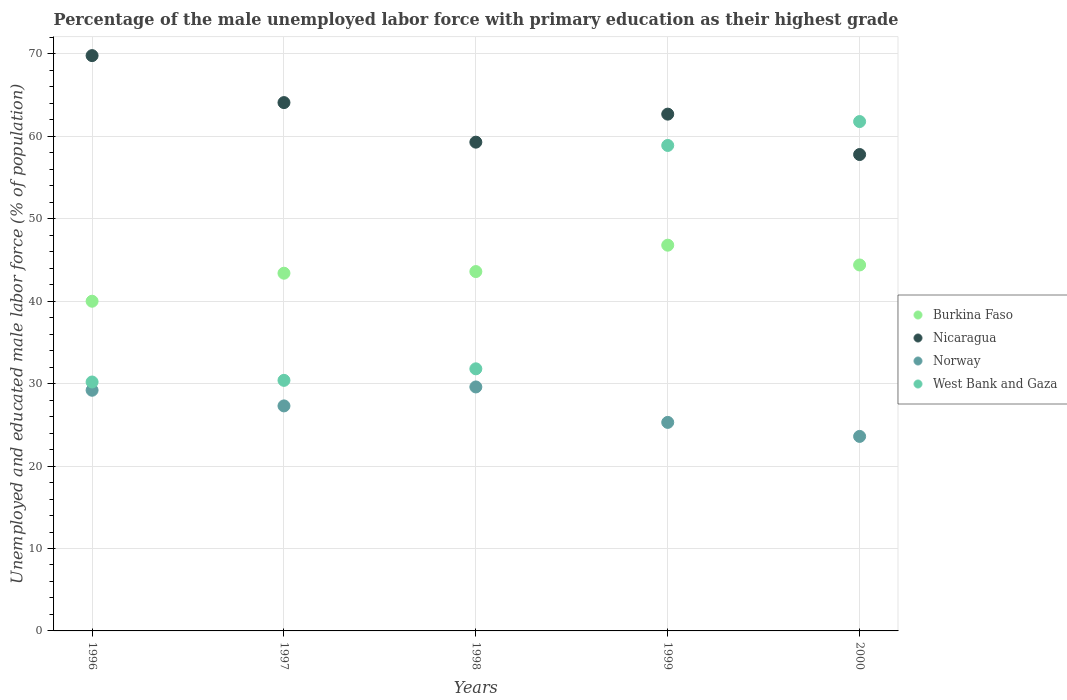How many different coloured dotlines are there?
Provide a short and direct response. 4. Is the number of dotlines equal to the number of legend labels?
Your answer should be compact. Yes. What is the percentage of the unemployed male labor force with primary education in West Bank and Gaza in 1999?
Offer a very short reply. 58.9. Across all years, what is the maximum percentage of the unemployed male labor force with primary education in West Bank and Gaza?
Offer a terse response. 61.8. Across all years, what is the minimum percentage of the unemployed male labor force with primary education in West Bank and Gaza?
Offer a very short reply. 30.2. In which year was the percentage of the unemployed male labor force with primary education in Norway maximum?
Keep it short and to the point. 1998. In which year was the percentage of the unemployed male labor force with primary education in Norway minimum?
Offer a terse response. 2000. What is the total percentage of the unemployed male labor force with primary education in Norway in the graph?
Your response must be concise. 135. What is the difference between the percentage of the unemployed male labor force with primary education in Nicaragua in 1997 and that in 2000?
Your response must be concise. 6.3. What is the difference between the percentage of the unemployed male labor force with primary education in Norway in 1998 and the percentage of the unemployed male labor force with primary education in Burkina Faso in 2000?
Keep it short and to the point. -14.8. What is the average percentage of the unemployed male labor force with primary education in West Bank and Gaza per year?
Offer a terse response. 42.62. In the year 1997, what is the difference between the percentage of the unemployed male labor force with primary education in Burkina Faso and percentage of the unemployed male labor force with primary education in West Bank and Gaza?
Give a very brief answer. 13. What is the ratio of the percentage of the unemployed male labor force with primary education in Burkina Faso in 1999 to that in 2000?
Offer a very short reply. 1.05. What is the difference between the highest and the second highest percentage of the unemployed male labor force with primary education in Nicaragua?
Provide a short and direct response. 5.7. What is the difference between the highest and the lowest percentage of the unemployed male labor force with primary education in Nicaragua?
Provide a succinct answer. 12. In how many years, is the percentage of the unemployed male labor force with primary education in West Bank and Gaza greater than the average percentage of the unemployed male labor force with primary education in West Bank and Gaza taken over all years?
Make the answer very short. 2. Is the sum of the percentage of the unemployed male labor force with primary education in Burkina Faso in 1998 and 2000 greater than the maximum percentage of the unemployed male labor force with primary education in West Bank and Gaza across all years?
Give a very brief answer. Yes. Is it the case that in every year, the sum of the percentage of the unemployed male labor force with primary education in Burkina Faso and percentage of the unemployed male labor force with primary education in West Bank and Gaza  is greater than the sum of percentage of the unemployed male labor force with primary education in Norway and percentage of the unemployed male labor force with primary education in Nicaragua?
Make the answer very short. Yes. Is it the case that in every year, the sum of the percentage of the unemployed male labor force with primary education in Nicaragua and percentage of the unemployed male labor force with primary education in West Bank and Gaza  is greater than the percentage of the unemployed male labor force with primary education in Burkina Faso?
Provide a short and direct response. Yes. Does the percentage of the unemployed male labor force with primary education in Nicaragua monotonically increase over the years?
Offer a very short reply. No. Is the percentage of the unemployed male labor force with primary education in Norway strictly less than the percentage of the unemployed male labor force with primary education in Burkina Faso over the years?
Your answer should be compact. Yes. How many dotlines are there?
Provide a succinct answer. 4. Are the values on the major ticks of Y-axis written in scientific E-notation?
Your answer should be very brief. No. Does the graph contain grids?
Give a very brief answer. Yes. How many legend labels are there?
Provide a short and direct response. 4. How are the legend labels stacked?
Your answer should be very brief. Vertical. What is the title of the graph?
Ensure brevity in your answer.  Percentage of the male unemployed labor force with primary education as their highest grade. What is the label or title of the X-axis?
Your response must be concise. Years. What is the label or title of the Y-axis?
Your answer should be compact. Unemployed and educated male labor force (% of population). What is the Unemployed and educated male labor force (% of population) in Nicaragua in 1996?
Make the answer very short. 69.8. What is the Unemployed and educated male labor force (% of population) of Norway in 1996?
Give a very brief answer. 29.2. What is the Unemployed and educated male labor force (% of population) of West Bank and Gaza in 1996?
Provide a succinct answer. 30.2. What is the Unemployed and educated male labor force (% of population) of Burkina Faso in 1997?
Give a very brief answer. 43.4. What is the Unemployed and educated male labor force (% of population) of Nicaragua in 1997?
Keep it short and to the point. 64.1. What is the Unemployed and educated male labor force (% of population) of Norway in 1997?
Your answer should be compact. 27.3. What is the Unemployed and educated male labor force (% of population) of West Bank and Gaza in 1997?
Give a very brief answer. 30.4. What is the Unemployed and educated male labor force (% of population) of Burkina Faso in 1998?
Give a very brief answer. 43.6. What is the Unemployed and educated male labor force (% of population) of Nicaragua in 1998?
Keep it short and to the point. 59.3. What is the Unemployed and educated male labor force (% of population) in Norway in 1998?
Provide a succinct answer. 29.6. What is the Unemployed and educated male labor force (% of population) of West Bank and Gaza in 1998?
Your response must be concise. 31.8. What is the Unemployed and educated male labor force (% of population) in Burkina Faso in 1999?
Provide a succinct answer. 46.8. What is the Unemployed and educated male labor force (% of population) of Nicaragua in 1999?
Provide a short and direct response. 62.7. What is the Unemployed and educated male labor force (% of population) of Norway in 1999?
Provide a short and direct response. 25.3. What is the Unemployed and educated male labor force (% of population) of West Bank and Gaza in 1999?
Offer a terse response. 58.9. What is the Unemployed and educated male labor force (% of population) of Burkina Faso in 2000?
Your answer should be very brief. 44.4. What is the Unemployed and educated male labor force (% of population) in Nicaragua in 2000?
Your answer should be compact. 57.8. What is the Unemployed and educated male labor force (% of population) in Norway in 2000?
Your response must be concise. 23.6. What is the Unemployed and educated male labor force (% of population) in West Bank and Gaza in 2000?
Your answer should be compact. 61.8. Across all years, what is the maximum Unemployed and educated male labor force (% of population) in Burkina Faso?
Provide a short and direct response. 46.8. Across all years, what is the maximum Unemployed and educated male labor force (% of population) in Nicaragua?
Your response must be concise. 69.8. Across all years, what is the maximum Unemployed and educated male labor force (% of population) of Norway?
Provide a short and direct response. 29.6. Across all years, what is the maximum Unemployed and educated male labor force (% of population) in West Bank and Gaza?
Make the answer very short. 61.8. Across all years, what is the minimum Unemployed and educated male labor force (% of population) in Burkina Faso?
Make the answer very short. 40. Across all years, what is the minimum Unemployed and educated male labor force (% of population) of Nicaragua?
Your answer should be compact. 57.8. Across all years, what is the minimum Unemployed and educated male labor force (% of population) in Norway?
Keep it short and to the point. 23.6. Across all years, what is the minimum Unemployed and educated male labor force (% of population) of West Bank and Gaza?
Offer a terse response. 30.2. What is the total Unemployed and educated male labor force (% of population) in Burkina Faso in the graph?
Give a very brief answer. 218.2. What is the total Unemployed and educated male labor force (% of population) in Nicaragua in the graph?
Provide a short and direct response. 313.7. What is the total Unemployed and educated male labor force (% of population) of Norway in the graph?
Provide a succinct answer. 135. What is the total Unemployed and educated male labor force (% of population) in West Bank and Gaza in the graph?
Your answer should be very brief. 213.1. What is the difference between the Unemployed and educated male labor force (% of population) of Burkina Faso in 1996 and that in 1997?
Provide a succinct answer. -3.4. What is the difference between the Unemployed and educated male labor force (% of population) in Nicaragua in 1996 and that in 1997?
Your answer should be very brief. 5.7. What is the difference between the Unemployed and educated male labor force (% of population) of Norway in 1996 and that in 1997?
Provide a short and direct response. 1.9. What is the difference between the Unemployed and educated male labor force (% of population) in Burkina Faso in 1996 and that in 1998?
Offer a terse response. -3.6. What is the difference between the Unemployed and educated male labor force (% of population) in Nicaragua in 1996 and that in 1998?
Ensure brevity in your answer.  10.5. What is the difference between the Unemployed and educated male labor force (% of population) in Norway in 1996 and that in 1998?
Give a very brief answer. -0.4. What is the difference between the Unemployed and educated male labor force (% of population) of West Bank and Gaza in 1996 and that in 1998?
Make the answer very short. -1.6. What is the difference between the Unemployed and educated male labor force (% of population) in West Bank and Gaza in 1996 and that in 1999?
Give a very brief answer. -28.7. What is the difference between the Unemployed and educated male labor force (% of population) of Nicaragua in 1996 and that in 2000?
Your answer should be very brief. 12. What is the difference between the Unemployed and educated male labor force (% of population) of West Bank and Gaza in 1996 and that in 2000?
Your response must be concise. -31.6. What is the difference between the Unemployed and educated male labor force (% of population) in Burkina Faso in 1997 and that in 1998?
Your answer should be compact. -0.2. What is the difference between the Unemployed and educated male labor force (% of population) in Norway in 1997 and that in 1998?
Your answer should be compact. -2.3. What is the difference between the Unemployed and educated male labor force (% of population) in Burkina Faso in 1997 and that in 1999?
Your answer should be compact. -3.4. What is the difference between the Unemployed and educated male labor force (% of population) of West Bank and Gaza in 1997 and that in 1999?
Provide a short and direct response. -28.5. What is the difference between the Unemployed and educated male labor force (% of population) of Nicaragua in 1997 and that in 2000?
Offer a terse response. 6.3. What is the difference between the Unemployed and educated male labor force (% of population) of West Bank and Gaza in 1997 and that in 2000?
Keep it short and to the point. -31.4. What is the difference between the Unemployed and educated male labor force (% of population) of Burkina Faso in 1998 and that in 1999?
Keep it short and to the point. -3.2. What is the difference between the Unemployed and educated male labor force (% of population) in West Bank and Gaza in 1998 and that in 1999?
Keep it short and to the point. -27.1. What is the difference between the Unemployed and educated male labor force (% of population) in Nicaragua in 1998 and that in 2000?
Provide a succinct answer. 1.5. What is the difference between the Unemployed and educated male labor force (% of population) of West Bank and Gaza in 1998 and that in 2000?
Your answer should be very brief. -30. What is the difference between the Unemployed and educated male labor force (% of population) in Nicaragua in 1999 and that in 2000?
Your answer should be compact. 4.9. What is the difference between the Unemployed and educated male labor force (% of population) of Norway in 1999 and that in 2000?
Provide a succinct answer. 1.7. What is the difference between the Unemployed and educated male labor force (% of population) of Burkina Faso in 1996 and the Unemployed and educated male labor force (% of population) of Nicaragua in 1997?
Make the answer very short. -24.1. What is the difference between the Unemployed and educated male labor force (% of population) of Nicaragua in 1996 and the Unemployed and educated male labor force (% of population) of Norway in 1997?
Provide a succinct answer. 42.5. What is the difference between the Unemployed and educated male labor force (% of population) in Nicaragua in 1996 and the Unemployed and educated male labor force (% of population) in West Bank and Gaza in 1997?
Your response must be concise. 39.4. What is the difference between the Unemployed and educated male labor force (% of population) of Norway in 1996 and the Unemployed and educated male labor force (% of population) of West Bank and Gaza in 1997?
Offer a very short reply. -1.2. What is the difference between the Unemployed and educated male labor force (% of population) of Burkina Faso in 1996 and the Unemployed and educated male labor force (% of population) of Nicaragua in 1998?
Ensure brevity in your answer.  -19.3. What is the difference between the Unemployed and educated male labor force (% of population) of Burkina Faso in 1996 and the Unemployed and educated male labor force (% of population) of Norway in 1998?
Your answer should be very brief. 10.4. What is the difference between the Unemployed and educated male labor force (% of population) of Nicaragua in 1996 and the Unemployed and educated male labor force (% of population) of Norway in 1998?
Provide a succinct answer. 40.2. What is the difference between the Unemployed and educated male labor force (% of population) in Norway in 1996 and the Unemployed and educated male labor force (% of population) in West Bank and Gaza in 1998?
Provide a succinct answer. -2.6. What is the difference between the Unemployed and educated male labor force (% of population) in Burkina Faso in 1996 and the Unemployed and educated male labor force (% of population) in Nicaragua in 1999?
Offer a very short reply. -22.7. What is the difference between the Unemployed and educated male labor force (% of population) of Burkina Faso in 1996 and the Unemployed and educated male labor force (% of population) of West Bank and Gaza in 1999?
Keep it short and to the point. -18.9. What is the difference between the Unemployed and educated male labor force (% of population) of Nicaragua in 1996 and the Unemployed and educated male labor force (% of population) of Norway in 1999?
Provide a succinct answer. 44.5. What is the difference between the Unemployed and educated male labor force (% of population) in Norway in 1996 and the Unemployed and educated male labor force (% of population) in West Bank and Gaza in 1999?
Your answer should be very brief. -29.7. What is the difference between the Unemployed and educated male labor force (% of population) in Burkina Faso in 1996 and the Unemployed and educated male labor force (% of population) in Nicaragua in 2000?
Make the answer very short. -17.8. What is the difference between the Unemployed and educated male labor force (% of population) of Burkina Faso in 1996 and the Unemployed and educated male labor force (% of population) of West Bank and Gaza in 2000?
Offer a terse response. -21.8. What is the difference between the Unemployed and educated male labor force (% of population) in Nicaragua in 1996 and the Unemployed and educated male labor force (% of population) in Norway in 2000?
Offer a very short reply. 46.2. What is the difference between the Unemployed and educated male labor force (% of population) in Norway in 1996 and the Unemployed and educated male labor force (% of population) in West Bank and Gaza in 2000?
Your answer should be compact. -32.6. What is the difference between the Unemployed and educated male labor force (% of population) of Burkina Faso in 1997 and the Unemployed and educated male labor force (% of population) of Nicaragua in 1998?
Offer a very short reply. -15.9. What is the difference between the Unemployed and educated male labor force (% of population) in Nicaragua in 1997 and the Unemployed and educated male labor force (% of population) in Norway in 1998?
Your response must be concise. 34.5. What is the difference between the Unemployed and educated male labor force (% of population) in Nicaragua in 1997 and the Unemployed and educated male labor force (% of population) in West Bank and Gaza in 1998?
Offer a terse response. 32.3. What is the difference between the Unemployed and educated male labor force (% of population) of Burkina Faso in 1997 and the Unemployed and educated male labor force (% of population) of Nicaragua in 1999?
Keep it short and to the point. -19.3. What is the difference between the Unemployed and educated male labor force (% of population) in Burkina Faso in 1997 and the Unemployed and educated male labor force (% of population) in West Bank and Gaza in 1999?
Your response must be concise. -15.5. What is the difference between the Unemployed and educated male labor force (% of population) in Nicaragua in 1997 and the Unemployed and educated male labor force (% of population) in Norway in 1999?
Give a very brief answer. 38.8. What is the difference between the Unemployed and educated male labor force (% of population) in Norway in 1997 and the Unemployed and educated male labor force (% of population) in West Bank and Gaza in 1999?
Your response must be concise. -31.6. What is the difference between the Unemployed and educated male labor force (% of population) in Burkina Faso in 1997 and the Unemployed and educated male labor force (% of population) in Nicaragua in 2000?
Ensure brevity in your answer.  -14.4. What is the difference between the Unemployed and educated male labor force (% of population) in Burkina Faso in 1997 and the Unemployed and educated male labor force (% of population) in Norway in 2000?
Ensure brevity in your answer.  19.8. What is the difference between the Unemployed and educated male labor force (% of population) in Burkina Faso in 1997 and the Unemployed and educated male labor force (% of population) in West Bank and Gaza in 2000?
Offer a terse response. -18.4. What is the difference between the Unemployed and educated male labor force (% of population) in Nicaragua in 1997 and the Unemployed and educated male labor force (% of population) in Norway in 2000?
Offer a very short reply. 40.5. What is the difference between the Unemployed and educated male labor force (% of population) in Norway in 1997 and the Unemployed and educated male labor force (% of population) in West Bank and Gaza in 2000?
Make the answer very short. -34.5. What is the difference between the Unemployed and educated male labor force (% of population) of Burkina Faso in 1998 and the Unemployed and educated male labor force (% of population) of Nicaragua in 1999?
Offer a very short reply. -19.1. What is the difference between the Unemployed and educated male labor force (% of population) in Burkina Faso in 1998 and the Unemployed and educated male labor force (% of population) in West Bank and Gaza in 1999?
Your answer should be compact. -15.3. What is the difference between the Unemployed and educated male labor force (% of population) in Nicaragua in 1998 and the Unemployed and educated male labor force (% of population) in Norway in 1999?
Give a very brief answer. 34. What is the difference between the Unemployed and educated male labor force (% of population) in Norway in 1998 and the Unemployed and educated male labor force (% of population) in West Bank and Gaza in 1999?
Ensure brevity in your answer.  -29.3. What is the difference between the Unemployed and educated male labor force (% of population) in Burkina Faso in 1998 and the Unemployed and educated male labor force (% of population) in West Bank and Gaza in 2000?
Ensure brevity in your answer.  -18.2. What is the difference between the Unemployed and educated male labor force (% of population) in Nicaragua in 1998 and the Unemployed and educated male labor force (% of population) in Norway in 2000?
Ensure brevity in your answer.  35.7. What is the difference between the Unemployed and educated male labor force (% of population) of Nicaragua in 1998 and the Unemployed and educated male labor force (% of population) of West Bank and Gaza in 2000?
Your answer should be compact. -2.5. What is the difference between the Unemployed and educated male labor force (% of population) in Norway in 1998 and the Unemployed and educated male labor force (% of population) in West Bank and Gaza in 2000?
Provide a succinct answer. -32.2. What is the difference between the Unemployed and educated male labor force (% of population) in Burkina Faso in 1999 and the Unemployed and educated male labor force (% of population) in Norway in 2000?
Keep it short and to the point. 23.2. What is the difference between the Unemployed and educated male labor force (% of population) of Burkina Faso in 1999 and the Unemployed and educated male labor force (% of population) of West Bank and Gaza in 2000?
Ensure brevity in your answer.  -15. What is the difference between the Unemployed and educated male labor force (% of population) of Nicaragua in 1999 and the Unemployed and educated male labor force (% of population) of Norway in 2000?
Make the answer very short. 39.1. What is the difference between the Unemployed and educated male labor force (% of population) of Norway in 1999 and the Unemployed and educated male labor force (% of population) of West Bank and Gaza in 2000?
Provide a short and direct response. -36.5. What is the average Unemployed and educated male labor force (% of population) in Burkina Faso per year?
Your answer should be compact. 43.64. What is the average Unemployed and educated male labor force (% of population) in Nicaragua per year?
Ensure brevity in your answer.  62.74. What is the average Unemployed and educated male labor force (% of population) in Norway per year?
Provide a succinct answer. 27. What is the average Unemployed and educated male labor force (% of population) in West Bank and Gaza per year?
Provide a short and direct response. 42.62. In the year 1996, what is the difference between the Unemployed and educated male labor force (% of population) in Burkina Faso and Unemployed and educated male labor force (% of population) in Nicaragua?
Offer a very short reply. -29.8. In the year 1996, what is the difference between the Unemployed and educated male labor force (% of population) of Burkina Faso and Unemployed and educated male labor force (% of population) of Norway?
Make the answer very short. 10.8. In the year 1996, what is the difference between the Unemployed and educated male labor force (% of population) of Nicaragua and Unemployed and educated male labor force (% of population) of Norway?
Make the answer very short. 40.6. In the year 1996, what is the difference between the Unemployed and educated male labor force (% of population) of Nicaragua and Unemployed and educated male labor force (% of population) of West Bank and Gaza?
Your answer should be very brief. 39.6. In the year 1997, what is the difference between the Unemployed and educated male labor force (% of population) of Burkina Faso and Unemployed and educated male labor force (% of population) of Nicaragua?
Keep it short and to the point. -20.7. In the year 1997, what is the difference between the Unemployed and educated male labor force (% of population) in Burkina Faso and Unemployed and educated male labor force (% of population) in West Bank and Gaza?
Provide a succinct answer. 13. In the year 1997, what is the difference between the Unemployed and educated male labor force (% of population) of Nicaragua and Unemployed and educated male labor force (% of population) of Norway?
Your answer should be compact. 36.8. In the year 1997, what is the difference between the Unemployed and educated male labor force (% of population) of Nicaragua and Unemployed and educated male labor force (% of population) of West Bank and Gaza?
Give a very brief answer. 33.7. In the year 1997, what is the difference between the Unemployed and educated male labor force (% of population) in Norway and Unemployed and educated male labor force (% of population) in West Bank and Gaza?
Keep it short and to the point. -3.1. In the year 1998, what is the difference between the Unemployed and educated male labor force (% of population) in Burkina Faso and Unemployed and educated male labor force (% of population) in Nicaragua?
Ensure brevity in your answer.  -15.7. In the year 1998, what is the difference between the Unemployed and educated male labor force (% of population) in Nicaragua and Unemployed and educated male labor force (% of population) in Norway?
Provide a short and direct response. 29.7. In the year 1998, what is the difference between the Unemployed and educated male labor force (% of population) of Norway and Unemployed and educated male labor force (% of population) of West Bank and Gaza?
Ensure brevity in your answer.  -2.2. In the year 1999, what is the difference between the Unemployed and educated male labor force (% of population) of Burkina Faso and Unemployed and educated male labor force (% of population) of Nicaragua?
Offer a terse response. -15.9. In the year 1999, what is the difference between the Unemployed and educated male labor force (% of population) of Burkina Faso and Unemployed and educated male labor force (% of population) of Norway?
Provide a short and direct response. 21.5. In the year 1999, what is the difference between the Unemployed and educated male labor force (% of population) in Burkina Faso and Unemployed and educated male labor force (% of population) in West Bank and Gaza?
Provide a succinct answer. -12.1. In the year 1999, what is the difference between the Unemployed and educated male labor force (% of population) of Nicaragua and Unemployed and educated male labor force (% of population) of Norway?
Ensure brevity in your answer.  37.4. In the year 1999, what is the difference between the Unemployed and educated male labor force (% of population) of Norway and Unemployed and educated male labor force (% of population) of West Bank and Gaza?
Your response must be concise. -33.6. In the year 2000, what is the difference between the Unemployed and educated male labor force (% of population) of Burkina Faso and Unemployed and educated male labor force (% of population) of Norway?
Your answer should be compact. 20.8. In the year 2000, what is the difference between the Unemployed and educated male labor force (% of population) in Burkina Faso and Unemployed and educated male labor force (% of population) in West Bank and Gaza?
Offer a terse response. -17.4. In the year 2000, what is the difference between the Unemployed and educated male labor force (% of population) in Nicaragua and Unemployed and educated male labor force (% of population) in Norway?
Your answer should be compact. 34.2. In the year 2000, what is the difference between the Unemployed and educated male labor force (% of population) in Nicaragua and Unemployed and educated male labor force (% of population) in West Bank and Gaza?
Your answer should be compact. -4. In the year 2000, what is the difference between the Unemployed and educated male labor force (% of population) of Norway and Unemployed and educated male labor force (% of population) of West Bank and Gaza?
Offer a terse response. -38.2. What is the ratio of the Unemployed and educated male labor force (% of population) in Burkina Faso in 1996 to that in 1997?
Your answer should be compact. 0.92. What is the ratio of the Unemployed and educated male labor force (% of population) of Nicaragua in 1996 to that in 1997?
Your response must be concise. 1.09. What is the ratio of the Unemployed and educated male labor force (% of population) in Norway in 1996 to that in 1997?
Ensure brevity in your answer.  1.07. What is the ratio of the Unemployed and educated male labor force (% of population) of Burkina Faso in 1996 to that in 1998?
Offer a terse response. 0.92. What is the ratio of the Unemployed and educated male labor force (% of population) in Nicaragua in 1996 to that in 1998?
Ensure brevity in your answer.  1.18. What is the ratio of the Unemployed and educated male labor force (% of population) of Norway in 1996 to that in 1998?
Provide a succinct answer. 0.99. What is the ratio of the Unemployed and educated male labor force (% of population) in West Bank and Gaza in 1996 to that in 1998?
Offer a very short reply. 0.95. What is the ratio of the Unemployed and educated male labor force (% of population) in Burkina Faso in 1996 to that in 1999?
Your response must be concise. 0.85. What is the ratio of the Unemployed and educated male labor force (% of population) of Nicaragua in 1996 to that in 1999?
Ensure brevity in your answer.  1.11. What is the ratio of the Unemployed and educated male labor force (% of population) of Norway in 1996 to that in 1999?
Offer a very short reply. 1.15. What is the ratio of the Unemployed and educated male labor force (% of population) of West Bank and Gaza in 1996 to that in 1999?
Give a very brief answer. 0.51. What is the ratio of the Unemployed and educated male labor force (% of population) in Burkina Faso in 1996 to that in 2000?
Provide a succinct answer. 0.9. What is the ratio of the Unemployed and educated male labor force (% of population) in Nicaragua in 1996 to that in 2000?
Your answer should be compact. 1.21. What is the ratio of the Unemployed and educated male labor force (% of population) in Norway in 1996 to that in 2000?
Keep it short and to the point. 1.24. What is the ratio of the Unemployed and educated male labor force (% of population) in West Bank and Gaza in 1996 to that in 2000?
Your answer should be compact. 0.49. What is the ratio of the Unemployed and educated male labor force (% of population) in Burkina Faso in 1997 to that in 1998?
Provide a succinct answer. 1. What is the ratio of the Unemployed and educated male labor force (% of population) of Nicaragua in 1997 to that in 1998?
Your answer should be very brief. 1.08. What is the ratio of the Unemployed and educated male labor force (% of population) of Norway in 1997 to that in 1998?
Make the answer very short. 0.92. What is the ratio of the Unemployed and educated male labor force (% of population) of West Bank and Gaza in 1997 to that in 1998?
Provide a succinct answer. 0.96. What is the ratio of the Unemployed and educated male labor force (% of population) in Burkina Faso in 1997 to that in 1999?
Ensure brevity in your answer.  0.93. What is the ratio of the Unemployed and educated male labor force (% of population) of Nicaragua in 1997 to that in 1999?
Your answer should be very brief. 1.02. What is the ratio of the Unemployed and educated male labor force (% of population) of Norway in 1997 to that in 1999?
Keep it short and to the point. 1.08. What is the ratio of the Unemployed and educated male labor force (% of population) of West Bank and Gaza in 1997 to that in 1999?
Offer a very short reply. 0.52. What is the ratio of the Unemployed and educated male labor force (% of population) in Burkina Faso in 1997 to that in 2000?
Offer a terse response. 0.98. What is the ratio of the Unemployed and educated male labor force (% of population) in Nicaragua in 1997 to that in 2000?
Your answer should be compact. 1.11. What is the ratio of the Unemployed and educated male labor force (% of population) of Norway in 1997 to that in 2000?
Ensure brevity in your answer.  1.16. What is the ratio of the Unemployed and educated male labor force (% of population) of West Bank and Gaza in 1997 to that in 2000?
Ensure brevity in your answer.  0.49. What is the ratio of the Unemployed and educated male labor force (% of population) of Burkina Faso in 1998 to that in 1999?
Offer a very short reply. 0.93. What is the ratio of the Unemployed and educated male labor force (% of population) of Nicaragua in 1998 to that in 1999?
Your response must be concise. 0.95. What is the ratio of the Unemployed and educated male labor force (% of population) in Norway in 1998 to that in 1999?
Make the answer very short. 1.17. What is the ratio of the Unemployed and educated male labor force (% of population) of West Bank and Gaza in 1998 to that in 1999?
Provide a succinct answer. 0.54. What is the ratio of the Unemployed and educated male labor force (% of population) of Burkina Faso in 1998 to that in 2000?
Provide a succinct answer. 0.98. What is the ratio of the Unemployed and educated male labor force (% of population) in Nicaragua in 1998 to that in 2000?
Ensure brevity in your answer.  1.03. What is the ratio of the Unemployed and educated male labor force (% of population) of Norway in 1998 to that in 2000?
Keep it short and to the point. 1.25. What is the ratio of the Unemployed and educated male labor force (% of population) in West Bank and Gaza in 1998 to that in 2000?
Make the answer very short. 0.51. What is the ratio of the Unemployed and educated male labor force (% of population) of Burkina Faso in 1999 to that in 2000?
Make the answer very short. 1.05. What is the ratio of the Unemployed and educated male labor force (% of population) of Nicaragua in 1999 to that in 2000?
Your response must be concise. 1.08. What is the ratio of the Unemployed and educated male labor force (% of population) of Norway in 1999 to that in 2000?
Keep it short and to the point. 1.07. What is the ratio of the Unemployed and educated male labor force (% of population) in West Bank and Gaza in 1999 to that in 2000?
Your response must be concise. 0.95. What is the difference between the highest and the second highest Unemployed and educated male labor force (% of population) of Nicaragua?
Give a very brief answer. 5.7. What is the difference between the highest and the second highest Unemployed and educated male labor force (% of population) in Norway?
Make the answer very short. 0.4. What is the difference between the highest and the second highest Unemployed and educated male labor force (% of population) in West Bank and Gaza?
Your answer should be very brief. 2.9. What is the difference between the highest and the lowest Unemployed and educated male labor force (% of population) of Burkina Faso?
Your answer should be very brief. 6.8. What is the difference between the highest and the lowest Unemployed and educated male labor force (% of population) of West Bank and Gaza?
Give a very brief answer. 31.6. 